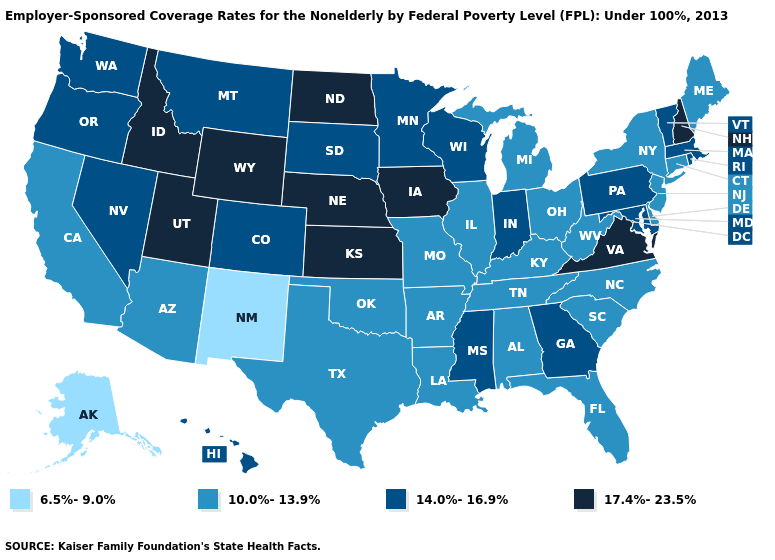Name the states that have a value in the range 6.5%-9.0%?
Be succinct. Alaska, New Mexico. Name the states that have a value in the range 17.4%-23.5%?
Be succinct. Idaho, Iowa, Kansas, Nebraska, New Hampshire, North Dakota, Utah, Virginia, Wyoming. What is the lowest value in the Northeast?
Answer briefly. 10.0%-13.9%. What is the value of South Dakota?
Be succinct. 14.0%-16.9%. Does the first symbol in the legend represent the smallest category?
Concise answer only. Yes. Does North Carolina have the highest value in the South?
Write a very short answer. No. Which states have the lowest value in the West?
Concise answer only. Alaska, New Mexico. Does the first symbol in the legend represent the smallest category?
Concise answer only. Yes. Name the states that have a value in the range 17.4%-23.5%?
Concise answer only. Idaho, Iowa, Kansas, Nebraska, New Hampshire, North Dakota, Utah, Virginia, Wyoming. What is the lowest value in the MidWest?
Keep it brief. 10.0%-13.9%. What is the highest value in states that border Ohio?
Give a very brief answer. 14.0%-16.9%. Name the states that have a value in the range 6.5%-9.0%?
Answer briefly. Alaska, New Mexico. What is the value of North Carolina?
Short answer required. 10.0%-13.9%. Name the states that have a value in the range 6.5%-9.0%?
Quick response, please. Alaska, New Mexico. Does the first symbol in the legend represent the smallest category?
Keep it brief. Yes. 